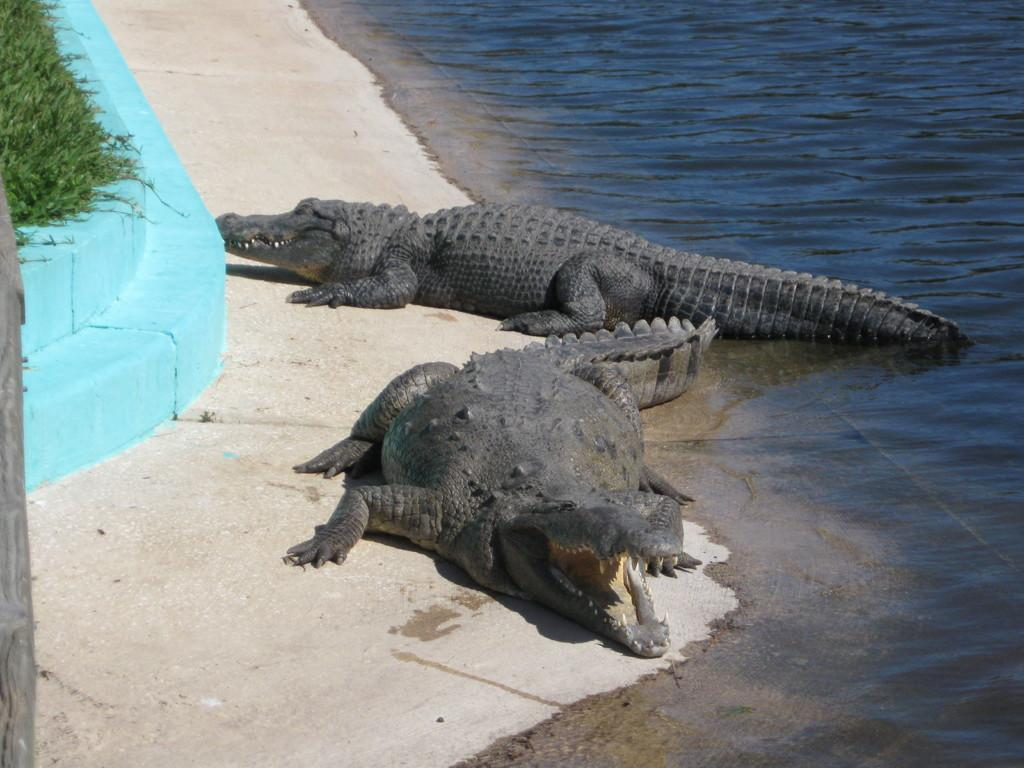What animals are located in the center of the image? There are crocodiles in the center of the image. What type of environment is visible in the background of the image? There is water, grass, and a wall visible in the background of the image. What type of creature can be seen shaking hands with the crocodiles in the image? There is no creature shaking hands with the crocodiles in the image; the crocodiles are the only animals present. 